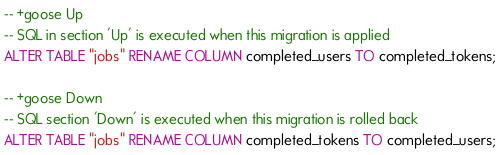Convert code to text. <code><loc_0><loc_0><loc_500><loc_500><_SQL_>-- +goose Up
-- SQL in section 'Up' is executed when this migration is applied
ALTER TABLE "jobs" RENAME COLUMN completed_users TO completed_tokens;

-- +goose Down
-- SQL section 'Down' is executed when this migration is rolled back
ALTER TABLE "jobs" RENAME COLUMN completed_tokens TO completed_users;
</code> 